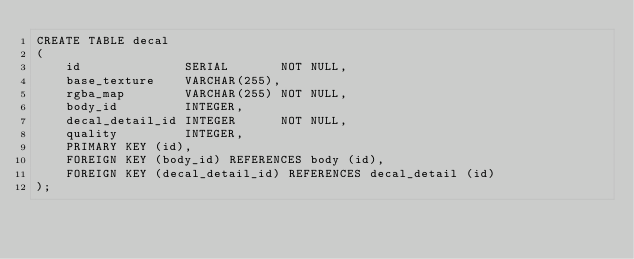<code> <loc_0><loc_0><loc_500><loc_500><_SQL_>CREATE TABLE decal
(
    id              SERIAL       NOT NULL,
    base_texture    VARCHAR(255),
    rgba_map        VARCHAR(255) NOT NULL,
    body_id         INTEGER,
    decal_detail_id INTEGER      NOT NULL,
    quality         INTEGER,
    PRIMARY KEY (id),
    FOREIGN KEY (body_id) REFERENCES body (id),
    FOREIGN KEY (decal_detail_id) REFERENCES decal_detail (id)
);
</code> 